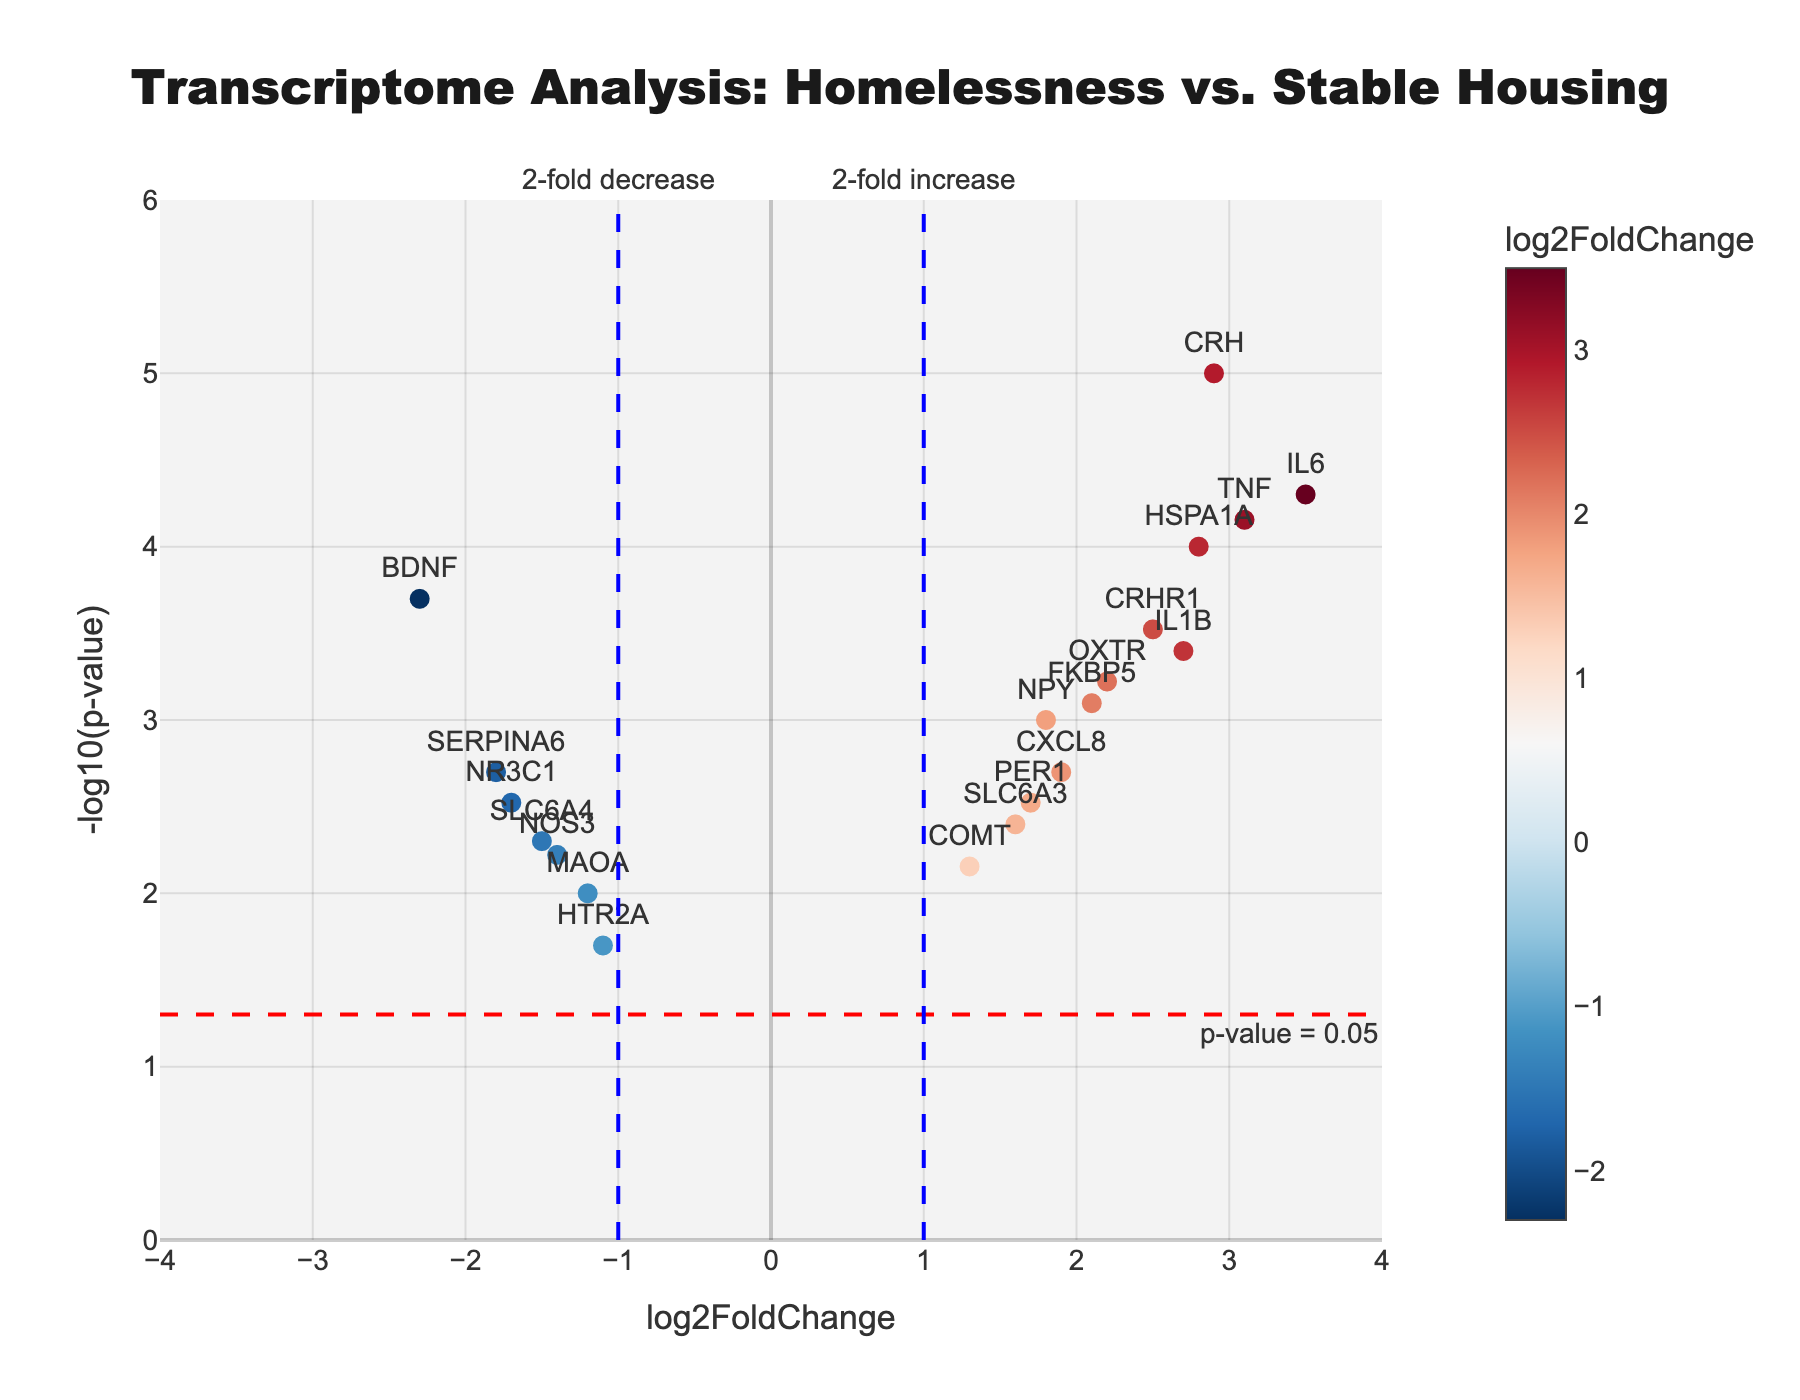What does the title of the plot say? The title of the plot is usually found at the top of the figure. For this plot, it reads "Transcriptome Analysis: Homelessness vs. Stable Housing."
Answer: Transcriptome Analysis: Homelessness vs. Stable Housing What are the axes of the plot labeled? The x-axis represents the log2FoldChange, which indicates the fold change on a log2 scale. The y-axis represents the -log10(p-value), which is the negative logarithm (base 10) of the p-value.
Answer: x-axis: log2FoldChange, y-axis: -log10(p-value) How many genes have a log2FoldChange greater than 2? By counting the points with a log2FoldChange greater than 2 along the x-axis, we see genes such as IL6, CRH, and TNF exceed this threshold. There are 4 genes in total.
Answer: 4 Which gene shows the highest log2FoldChange? By examining the points on the x-axis, the gene with the highest log2FoldChange is IL6 with a value of 3.5, as labeled on the plot.
Answer: IL6 What is the p-value threshold indicated on the plot? There is a horizontal dashed red line on the plot marked as "p-value = 0.05". This indicates a threshold where p-values below 0.05 are considered statistically significant.
Answer: 0.05 Which gene shows the lowest p-value? The gene with the lowest p-value will have the highest -log10(p-value) on the y-axis. By tracing the highest point on the y-axis, CRH with a p-value of 0.00001 is the lowest.
Answer: CRH Are there more genes with greater than 2-fold increase or decrease? By comparing the number of points to the right of the blue dashed line at 1 (greater than 2-fold increase) and the points to the left of the blue dashed line at -1 (greater than 2-fold decrease), there are more genes with a greater than 2-fold increase. There are 5 points on the right (increase) versus 4 points on the left (decrease).
Answer: More with greater than 2-fold increase How many genes have a significant p-value (below 0.05) and a fold change between -1 and 1? Significant p-values are below the red dashed line, and log2FoldChange between -1 and 1 indicates genes between the vertical blue lines negative 1 and 1. By counting these, we get FKBP5, NPY, COMT, PER1, SLC6A3. There are 5 such genes.
Answer: 5 Which two genes have the closest log2FoldChange values to each other? By looking at the x-axis positions and identifying the closest points, CXCL8 and PER1 both have log2FoldChange values close to 1.9 and 1.7, respectively. These values are the closest among the plotted genes.
Answer: CXCL8 and PER1 Which genes are overexpressed and significant (p-value < 0.05)? Overexpressed genes have log2FoldChange > 0 and significant p-values are below 0.05. By noting points right of the origin and also below the red line, HSPA1A, IL6, CXCL8, FKBP5, CRH, NPY, TNF, IL1B, OXTR, and CRHR1 fit these criteria. There are 10 such genes.
Answer: 10 